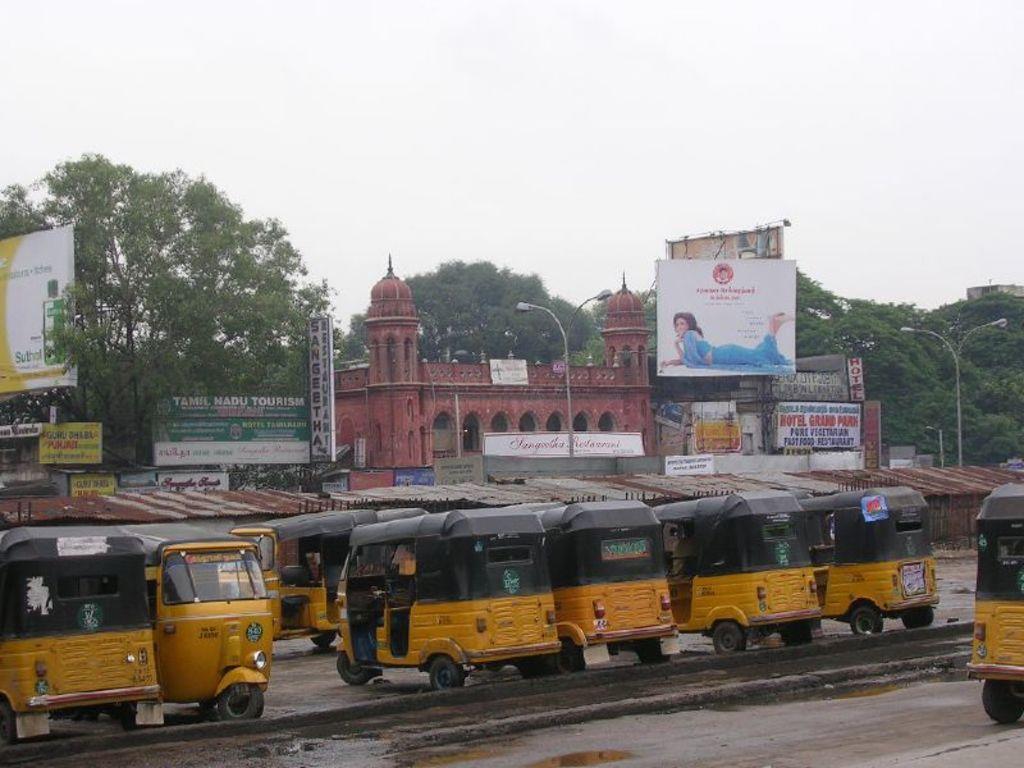How would you summarize this image in a sentence or two? In this image we can see many vehicles. Behind the vehicles we can see shed, buildings, advertisement boards, street poles with lights and a group of trees. At the top we can see the sky. 